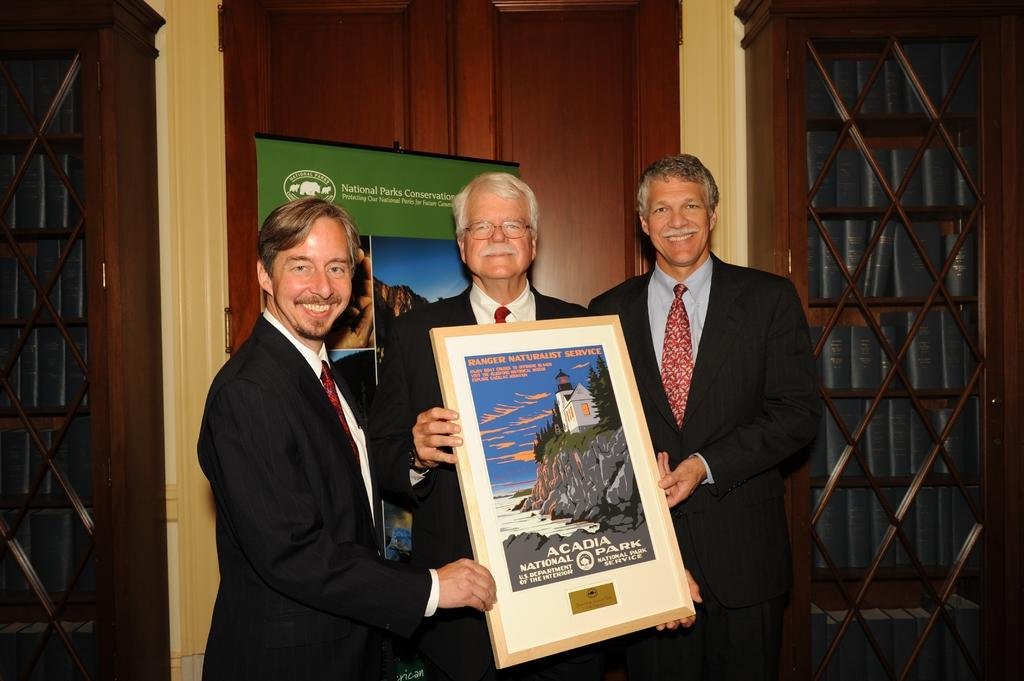What are the people in the image doing? The people in the center of the image are standing and smiling. What are the people holding in the image? The people are holding a frame. Can you describe the appearance of one of the people? One of the people is wearing glasses. What can be seen in the background of the image? There is a cupboard and doors in the background of the image. What type of jelly can be seen hanging from the frame in the image? There is no jelly present in the image, and therefore no such activity can be observed. 